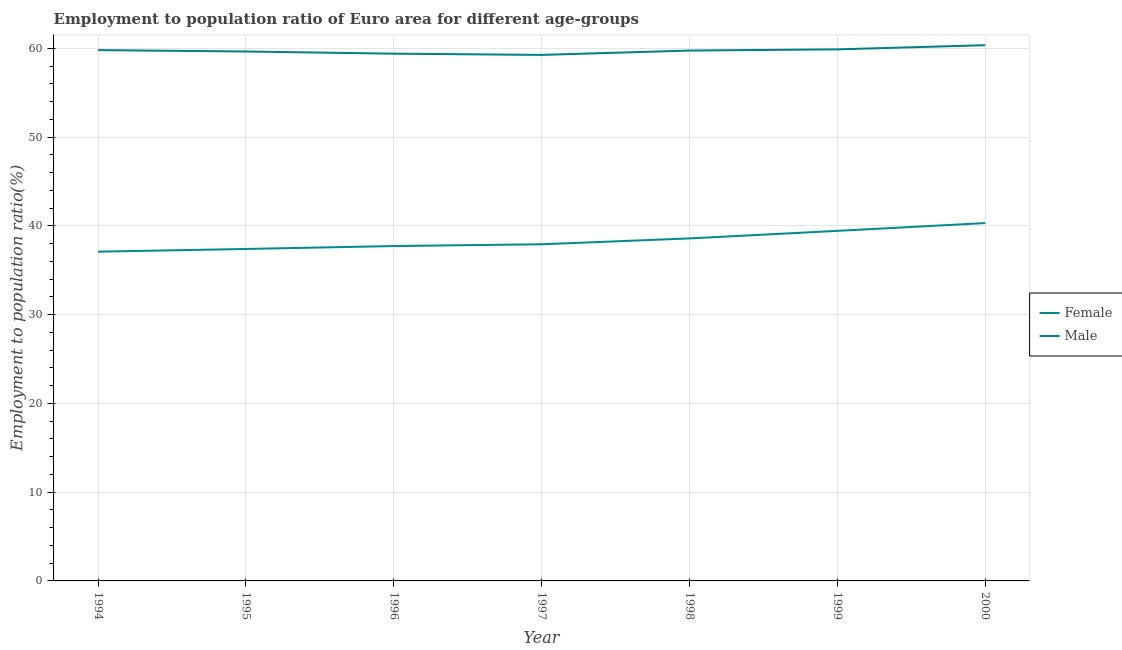How many different coloured lines are there?
Provide a succinct answer. 2. Is the number of lines equal to the number of legend labels?
Your response must be concise. Yes. What is the employment to population ratio(male) in 1995?
Give a very brief answer. 59.66. Across all years, what is the maximum employment to population ratio(female)?
Give a very brief answer. 40.32. Across all years, what is the minimum employment to population ratio(male)?
Give a very brief answer. 59.27. In which year was the employment to population ratio(female) minimum?
Keep it short and to the point. 1994. What is the total employment to population ratio(male) in the graph?
Your answer should be very brief. 418.19. What is the difference between the employment to population ratio(male) in 1995 and that in 1996?
Your answer should be very brief. 0.25. What is the difference between the employment to population ratio(female) in 1994 and the employment to population ratio(male) in 1999?
Offer a terse response. -22.8. What is the average employment to population ratio(male) per year?
Make the answer very short. 59.74. In the year 1996, what is the difference between the employment to population ratio(female) and employment to population ratio(male)?
Keep it short and to the point. -21.68. In how many years, is the employment to population ratio(female) greater than 18 %?
Your response must be concise. 7. What is the ratio of the employment to population ratio(female) in 1998 to that in 2000?
Provide a short and direct response. 0.96. Is the employment to population ratio(female) in 1995 less than that in 1998?
Offer a terse response. Yes. Is the difference between the employment to population ratio(male) in 1996 and 2000 greater than the difference between the employment to population ratio(female) in 1996 and 2000?
Keep it short and to the point. Yes. What is the difference between the highest and the second highest employment to population ratio(male)?
Your response must be concise. 0.47. What is the difference between the highest and the lowest employment to population ratio(male)?
Provide a short and direct response. 1.09. In how many years, is the employment to population ratio(male) greater than the average employment to population ratio(male) taken over all years?
Provide a succinct answer. 4. Does the employment to population ratio(female) monotonically increase over the years?
Your answer should be compact. Yes. Is the employment to population ratio(female) strictly greater than the employment to population ratio(male) over the years?
Keep it short and to the point. No. Is the employment to population ratio(female) strictly less than the employment to population ratio(male) over the years?
Provide a succinct answer. Yes. How many lines are there?
Provide a short and direct response. 2. How many years are there in the graph?
Offer a very short reply. 7. What is the difference between two consecutive major ticks on the Y-axis?
Make the answer very short. 10. Are the values on the major ticks of Y-axis written in scientific E-notation?
Offer a very short reply. No. How many legend labels are there?
Your answer should be very brief. 2. What is the title of the graph?
Give a very brief answer. Employment to population ratio of Euro area for different age-groups. What is the label or title of the Y-axis?
Give a very brief answer. Employment to population ratio(%). What is the Employment to population ratio(%) of Female in 1994?
Give a very brief answer. 37.1. What is the Employment to population ratio(%) in Male in 1994?
Give a very brief answer. 59.81. What is the Employment to population ratio(%) in Female in 1995?
Keep it short and to the point. 37.41. What is the Employment to population ratio(%) in Male in 1995?
Keep it short and to the point. 59.66. What is the Employment to population ratio(%) of Female in 1996?
Your response must be concise. 37.73. What is the Employment to population ratio(%) of Male in 1996?
Provide a succinct answer. 59.41. What is the Employment to population ratio(%) in Female in 1997?
Keep it short and to the point. 37.94. What is the Employment to population ratio(%) in Male in 1997?
Offer a very short reply. 59.27. What is the Employment to population ratio(%) in Female in 1998?
Provide a succinct answer. 38.59. What is the Employment to population ratio(%) in Male in 1998?
Your response must be concise. 59.76. What is the Employment to population ratio(%) in Female in 1999?
Your answer should be compact. 39.45. What is the Employment to population ratio(%) of Male in 1999?
Offer a terse response. 59.9. What is the Employment to population ratio(%) of Female in 2000?
Give a very brief answer. 40.32. What is the Employment to population ratio(%) of Male in 2000?
Provide a succinct answer. 60.37. Across all years, what is the maximum Employment to population ratio(%) in Female?
Your answer should be compact. 40.32. Across all years, what is the maximum Employment to population ratio(%) in Male?
Your answer should be compact. 60.37. Across all years, what is the minimum Employment to population ratio(%) in Female?
Make the answer very short. 37.1. Across all years, what is the minimum Employment to population ratio(%) of Male?
Make the answer very short. 59.27. What is the total Employment to population ratio(%) in Female in the graph?
Provide a short and direct response. 268.54. What is the total Employment to population ratio(%) in Male in the graph?
Offer a terse response. 418.19. What is the difference between the Employment to population ratio(%) of Female in 1994 and that in 1995?
Give a very brief answer. -0.3. What is the difference between the Employment to population ratio(%) of Male in 1994 and that in 1995?
Your response must be concise. 0.16. What is the difference between the Employment to population ratio(%) in Female in 1994 and that in 1996?
Ensure brevity in your answer.  -0.63. What is the difference between the Employment to population ratio(%) in Male in 1994 and that in 1996?
Your answer should be very brief. 0.4. What is the difference between the Employment to population ratio(%) in Female in 1994 and that in 1997?
Offer a terse response. -0.83. What is the difference between the Employment to population ratio(%) in Male in 1994 and that in 1997?
Keep it short and to the point. 0.54. What is the difference between the Employment to population ratio(%) of Female in 1994 and that in 1998?
Give a very brief answer. -1.49. What is the difference between the Employment to population ratio(%) in Male in 1994 and that in 1998?
Keep it short and to the point. 0.05. What is the difference between the Employment to population ratio(%) in Female in 1994 and that in 1999?
Offer a terse response. -2.35. What is the difference between the Employment to population ratio(%) in Male in 1994 and that in 1999?
Ensure brevity in your answer.  -0.08. What is the difference between the Employment to population ratio(%) in Female in 1994 and that in 2000?
Your answer should be very brief. -3.22. What is the difference between the Employment to population ratio(%) of Male in 1994 and that in 2000?
Your response must be concise. -0.55. What is the difference between the Employment to population ratio(%) in Female in 1995 and that in 1996?
Your answer should be very brief. -0.33. What is the difference between the Employment to population ratio(%) of Male in 1995 and that in 1996?
Offer a very short reply. 0.25. What is the difference between the Employment to population ratio(%) in Female in 1995 and that in 1997?
Make the answer very short. -0.53. What is the difference between the Employment to population ratio(%) of Male in 1995 and that in 1997?
Your answer should be very brief. 0.38. What is the difference between the Employment to population ratio(%) of Female in 1995 and that in 1998?
Make the answer very short. -1.19. What is the difference between the Employment to population ratio(%) in Male in 1995 and that in 1998?
Your response must be concise. -0.11. What is the difference between the Employment to population ratio(%) of Female in 1995 and that in 1999?
Your answer should be very brief. -2.04. What is the difference between the Employment to population ratio(%) in Male in 1995 and that in 1999?
Offer a terse response. -0.24. What is the difference between the Employment to population ratio(%) of Female in 1995 and that in 2000?
Your answer should be compact. -2.92. What is the difference between the Employment to population ratio(%) of Male in 1995 and that in 2000?
Make the answer very short. -0.71. What is the difference between the Employment to population ratio(%) in Female in 1996 and that in 1997?
Give a very brief answer. -0.2. What is the difference between the Employment to population ratio(%) of Male in 1996 and that in 1997?
Offer a terse response. 0.14. What is the difference between the Employment to population ratio(%) in Female in 1996 and that in 1998?
Offer a very short reply. -0.86. What is the difference between the Employment to population ratio(%) in Male in 1996 and that in 1998?
Keep it short and to the point. -0.35. What is the difference between the Employment to population ratio(%) of Female in 1996 and that in 1999?
Your response must be concise. -1.71. What is the difference between the Employment to population ratio(%) of Male in 1996 and that in 1999?
Provide a succinct answer. -0.49. What is the difference between the Employment to population ratio(%) of Female in 1996 and that in 2000?
Your response must be concise. -2.59. What is the difference between the Employment to population ratio(%) in Male in 1996 and that in 2000?
Offer a very short reply. -0.95. What is the difference between the Employment to population ratio(%) of Female in 1997 and that in 1998?
Ensure brevity in your answer.  -0.66. What is the difference between the Employment to population ratio(%) of Male in 1997 and that in 1998?
Offer a very short reply. -0.49. What is the difference between the Employment to population ratio(%) of Female in 1997 and that in 1999?
Offer a very short reply. -1.51. What is the difference between the Employment to population ratio(%) in Male in 1997 and that in 1999?
Offer a very short reply. -0.63. What is the difference between the Employment to population ratio(%) of Female in 1997 and that in 2000?
Keep it short and to the point. -2.39. What is the difference between the Employment to population ratio(%) of Male in 1997 and that in 2000?
Ensure brevity in your answer.  -1.09. What is the difference between the Employment to population ratio(%) in Female in 1998 and that in 1999?
Offer a terse response. -0.85. What is the difference between the Employment to population ratio(%) of Male in 1998 and that in 1999?
Provide a short and direct response. -0.13. What is the difference between the Employment to population ratio(%) of Female in 1998 and that in 2000?
Provide a short and direct response. -1.73. What is the difference between the Employment to population ratio(%) in Male in 1998 and that in 2000?
Provide a succinct answer. -0.6. What is the difference between the Employment to population ratio(%) of Female in 1999 and that in 2000?
Provide a succinct answer. -0.88. What is the difference between the Employment to population ratio(%) in Male in 1999 and that in 2000?
Your answer should be compact. -0.47. What is the difference between the Employment to population ratio(%) of Female in 1994 and the Employment to population ratio(%) of Male in 1995?
Your answer should be very brief. -22.56. What is the difference between the Employment to population ratio(%) in Female in 1994 and the Employment to population ratio(%) in Male in 1996?
Ensure brevity in your answer.  -22.31. What is the difference between the Employment to population ratio(%) of Female in 1994 and the Employment to population ratio(%) of Male in 1997?
Your response must be concise. -22.17. What is the difference between the Employment to population ratio(%) of Female in 1994 and the Employment to population ratio(%) of Male in 1998?
Your answer should be compact. -22.66. What is the difference between the Employment to population ratio(%) in Female in 1994 and the Employment to population ratio(%) in Male in 1999?
Your answer should be very brief. -22.8. What is the difference between the Employment to population ratio(%) of Female in 1994 and the Employment to population ratio(%) of Male in 2000?
Your answer should be compact. -23.27. What is the difference between the Employment to population ratio(%) in Female in 1995 and the Employment to population ratio(%) in Male in 1996?
Your answer should be very brief. -22.01. What is the difference between the Employment to population ratio(%) in Female in 1995 and the Employment to population ratio(%) in Male in 1997?
Keep it short and to the point. -21.87. What is the difference between the Employment to population ratio(%) of Female in 1995 and the Employment to population ratio(%) of Male in 1998?
Ensure brevity in your answer.  -22.36. What is the difference between the Employment to population ratio(%) of Female in 1995 and the Employment to population ratio(%) of Male in 1999?
Provide a succinct answer. -22.49. What is the difference between the Employment to population ratio(%) in Female in 1995 and the Employment to population ratio(%) in Male in 2000?
Offer a very short reply. -22.96. What is the difference between the Employment to population ratio(%) in Female in 1996 and the Employment to population ratio(%) in Male in 1997?
Your answer should be very brief. -21.54. What is the difference between the Employment to population ratio(%) of Female in 1996 and the Employment to population ratio(%) of Male in 1998?
Give a very brief answer. -22.03. What is the difference between the Employment to population ratio(%) of Female in 1996 and the Employment to population ratio(%) of Male in 1999?
Make the answer very short. -22.16. What is the difference between the Employment to population ratio(%) of Female in 1996 and the Employment to population ratio(%) of Male in 2000?
Offer a very short reply. -22.63. What is the difference between the Employment to population ratio(%) in Female in 1997 and the Employment to population ratio(%) in Male in 1998?
Keep it short and to the point. -21.83. What is the difference between the Employment to population ratio(%) in Female in 1997 and the Employment to population ratio(%) in Male in 1999?
Make the answer very short. -21.96. What is the difference between the Employment to population ratio(%) in Female in 1997 and the Employment to population ratio(%) in Male in 2000?
Your answer should be compact. -22.43. What is the difference between the Employment to population ratio(%) in Female in 1998 and the Employment to population ratio(%) in Male in 1999?
Give a very brief answer. -21.3. What is the difference between the Employment to population ratio(%) in Female in 1998 and the Employment to population ratio(%) in Male in 2000?
Give a very brief answer. -21.77. What is the difference between the Employment to population ratio(%) of Female in 1999 and the Employment to population ratio(%) of Male in 2000?
Ensure brevity in your answer.  -20.92. What is the average Employment to population ratio(%) in Female per year?
Make the answer very short. 38.36. What is the average Employment to population ratio(%) of Male per year?
Your answer should be compact. 59.74. In the year 1994, what is the difference between the Employment to population ratio(%) of Female and Employment to population ratio(%) of Male?
Give a very brief answer. -22.71. In the year 1995, what is the difference between the Employment to population ratio(%) in Female and Employment to population ratio(%) in Male?
Offer a terse response. -22.25. In the year 1996, what is the difference between the Employment to population ratio(%) in Female and Employment to population ratio(%) in Male?
Provide a succinct answer. -21.68. In the year 1997, what is the difference between the Employment to population ratio(%) in Female and Employment to population ratio(%) in Male?
Your answer should be very brief. -21.34. In the year 1998, what is the difference between the Employment to population ratio(%) of Female and Employment to population ratio(%) of Male?
Keep it short and to the point. -21.17. In the year 1999, what is the difference between the Employment to population ratio(%) of Female and Employment to population ratio(%) of Male?
Offer a terse response. -20.45. In the year 2000, what is the difference between the Employment to population ratio(%) of Female and Employment to population ratio(%) of Male?
Your response must be concise. -20.04. What is the ratio of the Employment to population ratio(%) in Male in 1994 to that in 1995?
Your answer should be very brief. 1. What is the ratio of the Employment to population ratio(%) of Female in 1994 to that in 1996?
Your answer should be compact. 0.98. What is the ratio of the Employment to population ratio(%) of Male in 1994 to that in 1996?
Offer a very short reply. 1.01. What is the ratio of the Employment to population ratio(%) in Male in 1994 to that in 1997?
Your answer should be very brief. 1.01. What is the ratio of the Employment to population ratio(%) in Female in 1994 to that in 1998?
Make the answer very short. 0.96. What is the ratio of the Employment to population ratio(%) in Female in 1994 to that in 1999?
Keep it short and to the point. 0.94. What is the ratio of the Employment to population ratio(%) in Male in 1994 to that in 1999?
Ensure brevity in your answer.  1. What is the ratio of the Employment to population ratio(%) of Female in 1994 to that in 2000?
Your answer should be compact. 0.92. What is the ratio of the Employment to population ratio(%) of Male in 1994 to that in 2000?
Offer a terse response. 0.99. What is the ratio of the Employment to population ratio(%) in Female in 1995 to that in 1996?
Offer a terse response. 0.99. What is the ratio of the Employment to population ratio(%) of Male in 1995 to that in 1996?
Give a very brief answer. 1. What is the ratio of the Employment to population ratio(%) of Female in 1995 to that in 1997?
Keep it short and to the point. 0.99. What is the ratio of the Employment to population ratio(%) of Male in 1995 to that in 1997?
Your answer should be compact. 1.01. What is the ratio of the Employment to population ratio(%) of Female in 1995 to that in 1998?
Your answer should be very brief. 0.97. What is the ratio of the Employment to population ratio(%) of Male in 1995 to that in 1998?
Give a very brief answer. 1. What is the ratio of the Employment to population ratio(%) of Female in 1995 to that in 1999?
Your answer should be very brief. 0.95. What is the ratio of the Employment to population ratio(%) in Male in 1995 to that in 1999?
Provide a short and direct response. 1. What is the ratio of the Employment to population ratio(%) of Female in 1995 to that in 2000?
Your response must be concise. 0.93. What is the ratio of the Employment to population ratio(%) of Male in 1995 to that in 2000?
Provide a short and direct response. 0.99. What is the ratio of the Employment to population ratio(%) of Male in 1996 to that in 1997?
Provide a succinct answer. 1. What is the ratio of the Employment to population ratio(%) in Female in 1996 to that in 1998?
Your response must be concise. 0.98. What is the ratio of the Employment to population ratio(%) in Male in 1996 to that in 1998?
Offer a terse response. 0.99. What is the ratio of the Employment to population ratio(%) in Female in 1996 to that in 1999?
Provide a short and direct response. 0.96. What is the ratio of the Employment to population ratio(%) in Male in 1996 to that in 1999?
Offer a very short reply. 0.99. What is the ratio of the Employment to population ratio(%) in Female in 1996 to that in 2000?
Provide a succinct answer. 0.94. What is the ratio of the Employment to population ratio(%) in Male in 1996 to that in 2000?
Your answer should be compact. 0.98. What is the ratio of the Employment to population ratio(%) of Female in 1997 to that in 1998?
Provide a short and direct response. 0.98. What is the ratio of the Employment to population ratio(%) in Female in 1997 to that in 1999?
Keep it short and to the point. 0.96. What is the ratio of the Employment to population ratio(%) in Female in 1997 to that in 2000?
Give a very brief answer. 0.94. What is the ratio of the Employment to population ratio(%) of Male in 1997 to that in 2000?
Your answer should be compact. 0.98. What is the ratio of the Employment to population ratio(%) in Female in 1998 to that in 1999?
Ensure brevity in your answer.  0.98. What is the ratio of the Employment to population ratio(%) in Male in 1998 to that in 1999?
Your answer should be very brief. 1. What is the ratio of the Employment to population ratio(%) of Female in 1998 to that in 2000?
Give a very brief answer. 0.96. What is the ratio of the Employment to population ratio(%) of Female in 1999 to that in 2000?
Provide a succinct answer. 0.98. What is the difference between the highest and the second highest Employment to population ratio(%) of Female?
Keep it short and to the point. 0.88. What is the difference between the highest and the second highest Employment to population ratio(%) of Male?
Your answer should be compact. 0.47. What is the difference between the highest and the lowest Employment to population ratio(%) in Female?
Provide a short and direct response. 3.22. What is the difference between the highest and the lowest Employment to population ratio(%) in Male?
Keep it short and to the point. 1.09. 